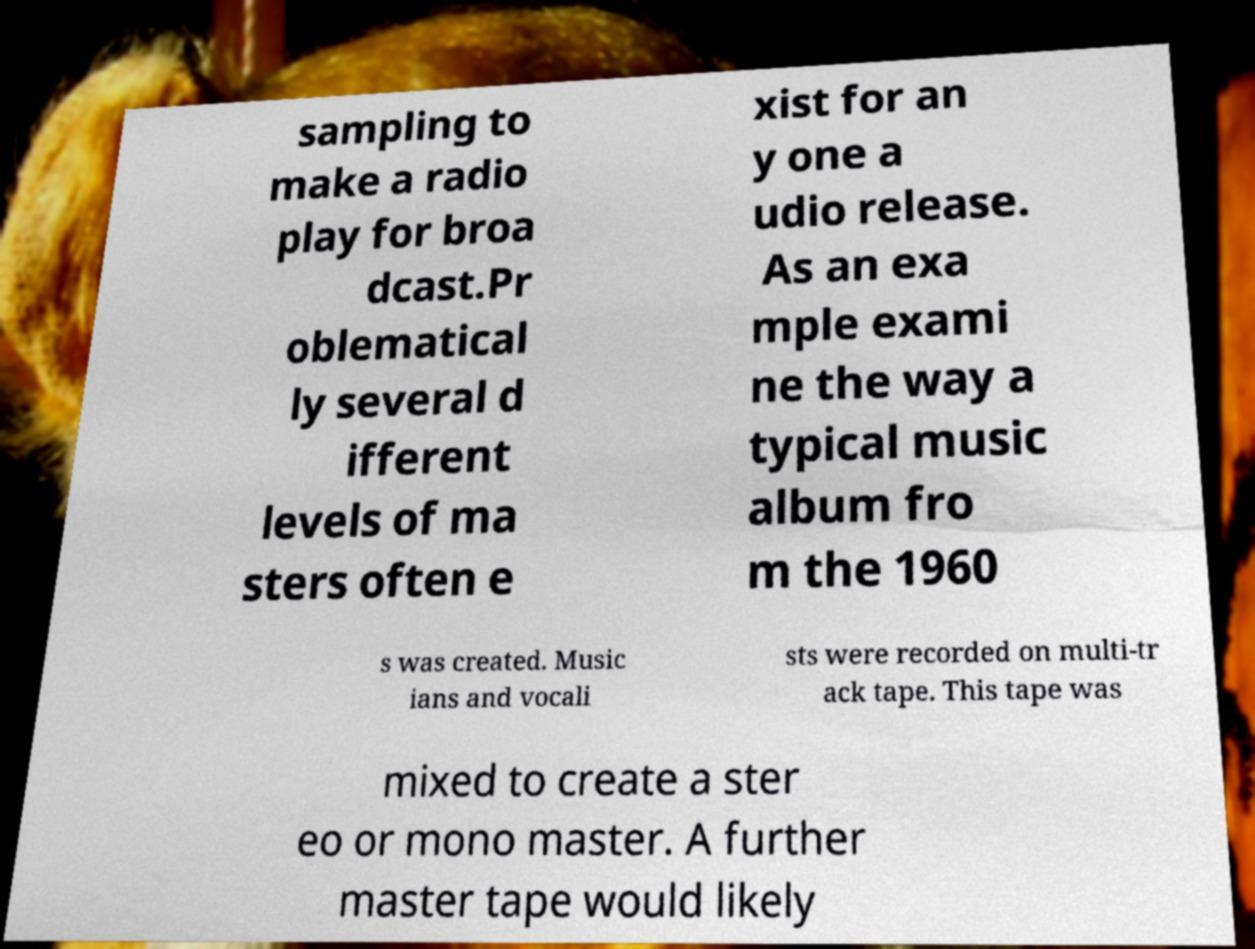Can you read and provide the text displayed in the image?This photo seems to have some interesting text. Can you extract and type it out for me? sampling to make a radio play for broa dcast.Pr oblematical ly several d ifferent levels of ma sters often e xist for an y one a udio release. As an exa mple exami ne the way a typical music album fro m the 1960 s was created. Music ians and vocali sts were recorded on multi-tr ack tape. This tape was mixed to create a ster eo or mono master. A further master tape would likely 